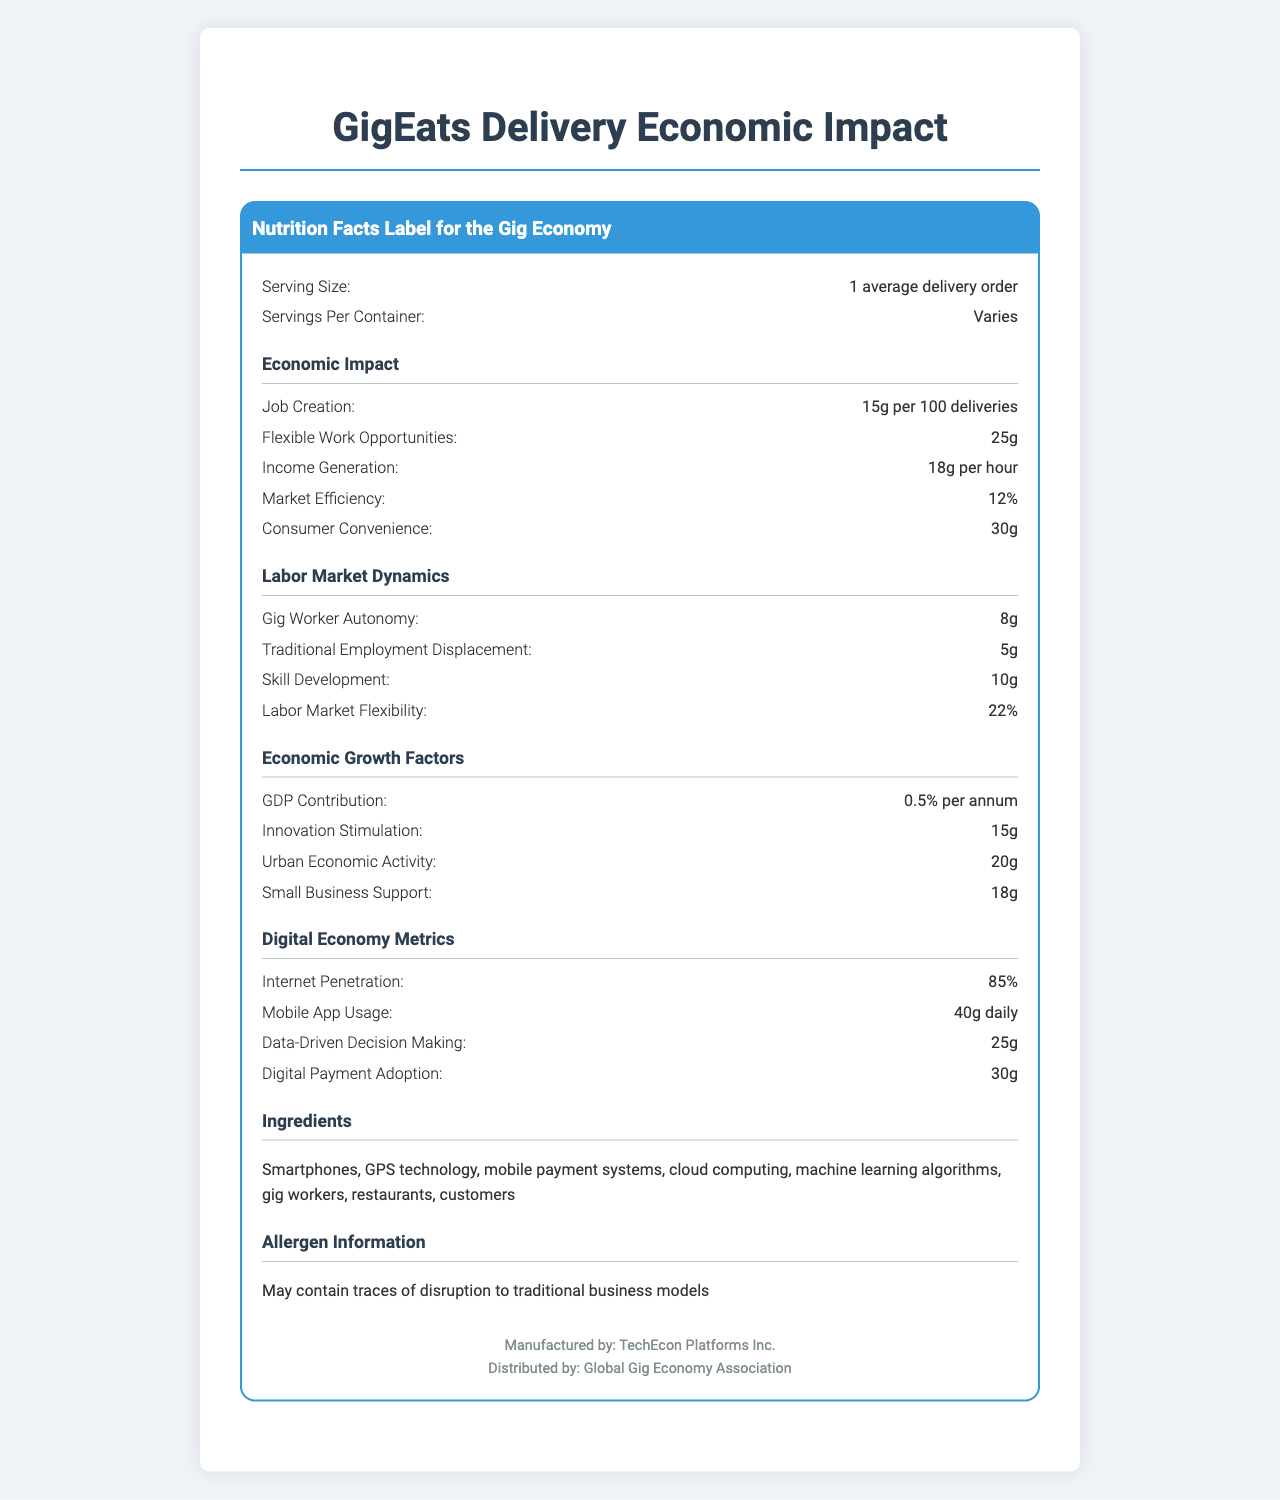what is the serving size? The serving size is listed in the first section of the document as "1 average delivery order".
Answer: 1 average delivery order how much job creation per 100 deliveries? Under the "Economic Impact" section, job creation is stated as "15g per 100 deliveries".
Answer: 15g what is the income generation per hour? In the "Economic Impact" section, it mentions "Income Generation: 18g per hour".
Answer: 18g how does urban mobility improve? The "Socioeconomic Factors" section states that urban mobility improves by 15g.
Answer: Improves by 15g how flexible is the labor market? The "Labor Market Dynamics" section indicates labor market flexibility as "Labor Market Flexibility: 22%".
Answer: 22% what element may increase consumer convenience? A. Job Creation B. Flexible Work Opportunities C. Income Generation D. Consumer Convenience The "Economic Impact" section lists "Consumer Convenience: 30g".
Answer: D how much does GDP contribution increase per annum? A. 0.1% B. 0.25% C. 0.5% D. 1% The "Economic Growth Factors" section indicates "GDP Contribution: 0.5% per annum".
Answer: C is data-driven decision making measured? The "Digital Economy Metrics" section measures data-driven decision making as "25g".
Answer: Yes does the gig economy impact traditional employment? It is stated in the "Labor Market Dynamics" section as "Traditional Employment Displacement: 5g".
Answer: Yes what are the main ideas of the document? The document details how gig economy jobs through GigEats Delivery contribute to job creation, flexibility, and income generation while affecting market efficiency and consumer convenience. It also covers other economic growth factors, digital economy metrics, labor market dynamics, and regulatory considerations, providing a holistic view of its economic impact.
Answer: The document provides a comprehensive analysis of the economic impact of GigEats Delivery on various aspects of the economy including job creation, flexible work opportunities, income generation, market efficiency, and consumer convenience. It evaluates the effects on labor market dynamics, economic growth, the digital economy, regulatory considerations, socioeconomic factors, platform economics, and sustainability. how much does the carbon footprint increase per delivery? The "Sustainability Metrics" section states the carbon footprint as "150g CO2 per delivery".
Answer: 150g CO2 per delivery how is data valuation represented? According to the "Platform Economics" section, data valuation is "$0.50 per order".
Answer: $0.50 per order how much is packaging waste per order? The "Sustainability Metrics" section indicates that packaging waste is "30g per order".
Answer: 30g per order which category is machine learning algorithms used in? Machine learning algorithms are listed under "Ingredients".
Answer: Ingredients what is the internet penetration rate? The "Digital Economy Metrics" section indicates "Internet Penetration: 85%".
Answer: 85% who distributes the service? The document footer mentions that it is distributed by "Global Gig Economy Association".
Answer: Global Gig Economy Association what could be the potential effect on income inequality? The "Socioeconomic Factors" section states that income inequality may increase by 3g.
Answer: May increase by 3g what is the exact income generation, market efficiency, and consumer convenience impact? Only aggregated values for income generation, market efficiency, and consumer convenience are provided, detailed effects or specific contexts are not mentioned in the document, thus making it insufficient to answer this precisely.
Answer: Not enough information 